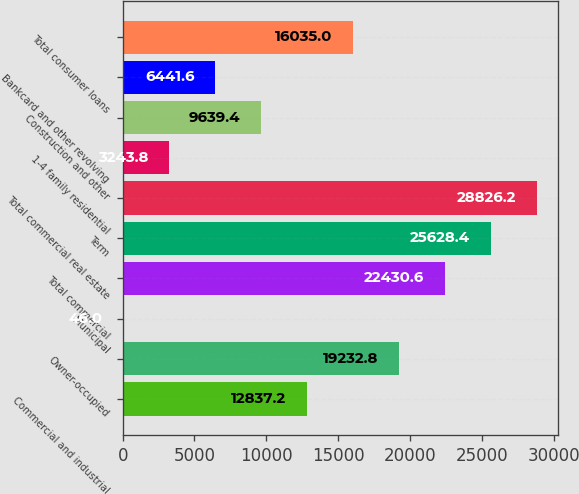Convert chart. <chart><loc_0><loc_0><loc_500><loc_500><bar_chart><fcel>Commercial and industrial<fcel>Owner-occupied<fcel>Municipal<fcel>Total commercial<fcel>Term<fcel>Total commercial real estate<fcel>1-4 family residential<fcel>Construction and other<fcel>Bankcard and other revolving<fcel>Total consumer loans<nl><fcel>12837.2<fcel>19232.8<fcel>46<fcel>22430.6<fcel>25628.4<fcel>28826.2<fcel>3243.8<fcel>9639.4<fcel>6441.6<fcel>16035<nl></chart> 